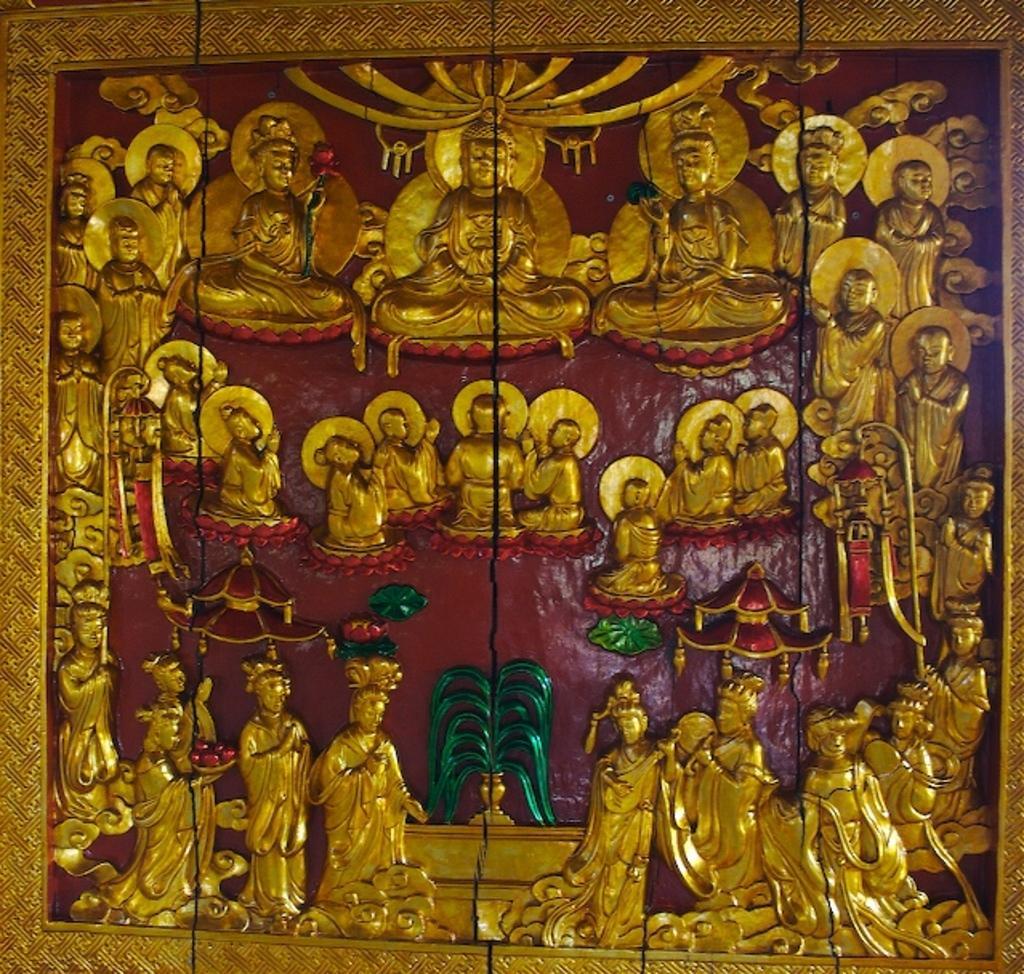Could you give a brief overview of what you see in this image? In this image there are sculptures on the wall, the background of the image is red in color. 